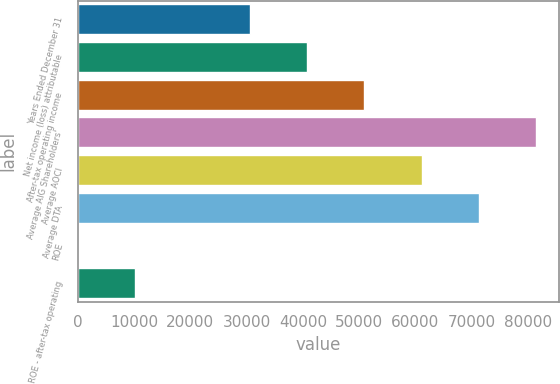Convert chart. <chart><loc_0><loc_0><loc_500><loc_500><bar_chart><fcel>Years Ended December 31<fcel>Net income (loss) attributable<fcel>After-tax operating income<fcel>Average AIG Shareholders'<fcel>Average AOCI<fcel>Average DTA<fcel>ROE<fcel>ROE - after-tax operating<nl><fcel>30564.3<fcel>40751.2<fcel>50938.2<fcel>81499.1<fcel>61125.2<fcel>71312.1<fcel>3.4<fcel>10190.4<nl></chart> 